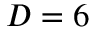Convert formula to latex. <formula><loc_0><loc_0><loc_500><loc_500>D = 6</formula> 